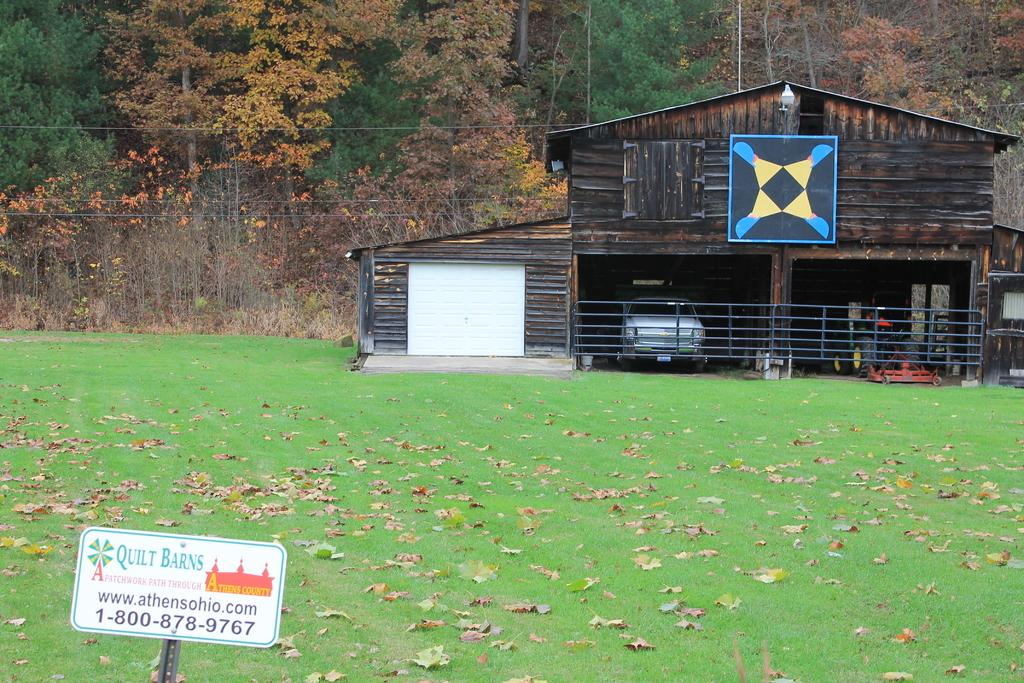What type of vegetation can be seen in the image? There are trees in the image. What structure is located on the right side of the image? There is a vehicles shed on the right side of the image. What is present on the grass in the image? There are dry leaves on the grass. Where is the board located in the image? The board is in the bottom left of the image. What type of pleasure can be seen enjoying the board in the image? There is no indication of pleasure or any person enjoying the board in the image. Can you tell me what the uncle is doing in the image? There is no uncle present in the image. What type of blade is being used to cut the dry leaves in the image? There is no blade or cutting activity present in the image. 